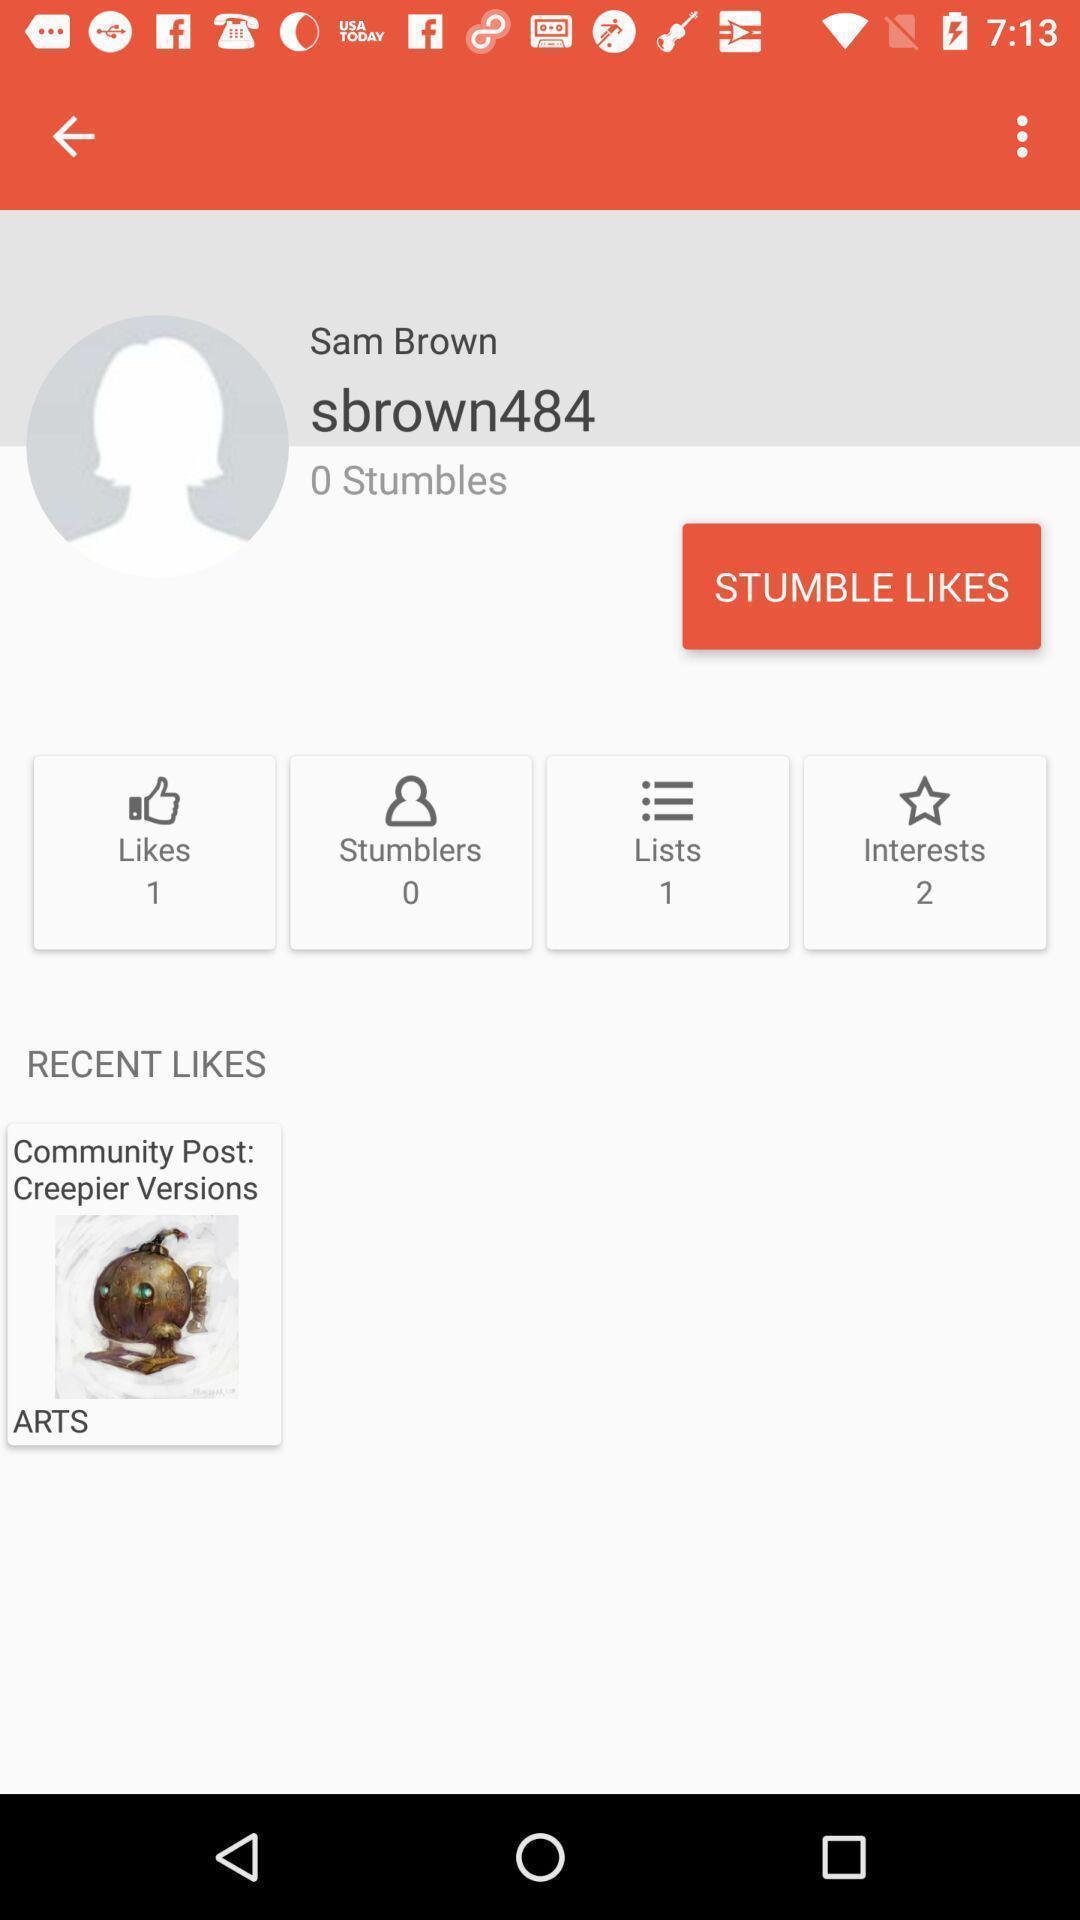Tell me what you see in this picture. Page is displaying about social app. 